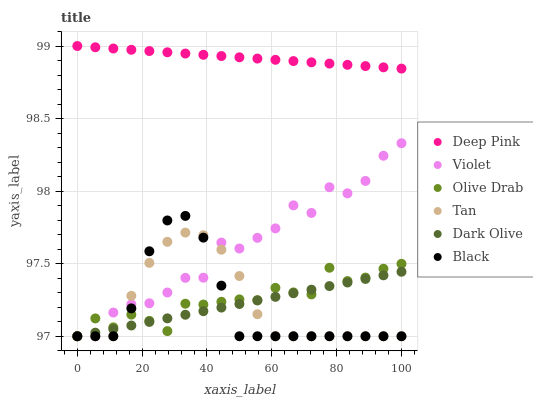Does Black have the minimum area under the curve?
Answer yes or no. Yes. Does Deep Pink have the maximum area under the curve?
Answer yes or no. Yes. Does Dark Olive have the minimum area under the curve?
Answer yes or no. No. Does Dark Olive have the maximum area under the curve?
Answer yes or no. No. Is Deep Pink the smoothest?
Answer yes or no. Yes. Is Violet the roughest?
Answer yes or no. Yes. Is Dark Olive the smoothest?
Answer yes or no. No. Is Dark Olive the roughest?
Answer yes or no. No. Does Dark Olive have the lowest value?
Answer yes or no. Yes. Does Deep Pink have the highest value?
Answer yes or no. Yes. Does Black have the highest value?
Answer yes or no. No. Is Violet less than Deep Pink?
Answer yes or no. Yes. Is Deep Pink greater than Violet?
Answer yes or no. Yes. Does Black intersect Olive Drab?
Answer yes or no. Yes. Is Black less than Olive Drab?
Answer yes or no. No. Is Black greater than Olive Drab?
Answer yes or no. No. Does Violet intersect Deep Pink?
Answer yes or no. No. 